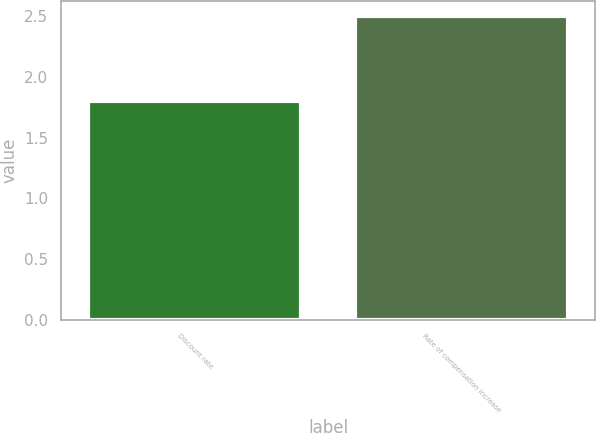Convert chart to OTSL. <chart><loc_0><loc_0><loc_500><loc_500><bar_chart><fcel>Discount rate<fcel>Rate of compensation increase<nl><fcel>1.8<fcel>2.5<nl></chart> 